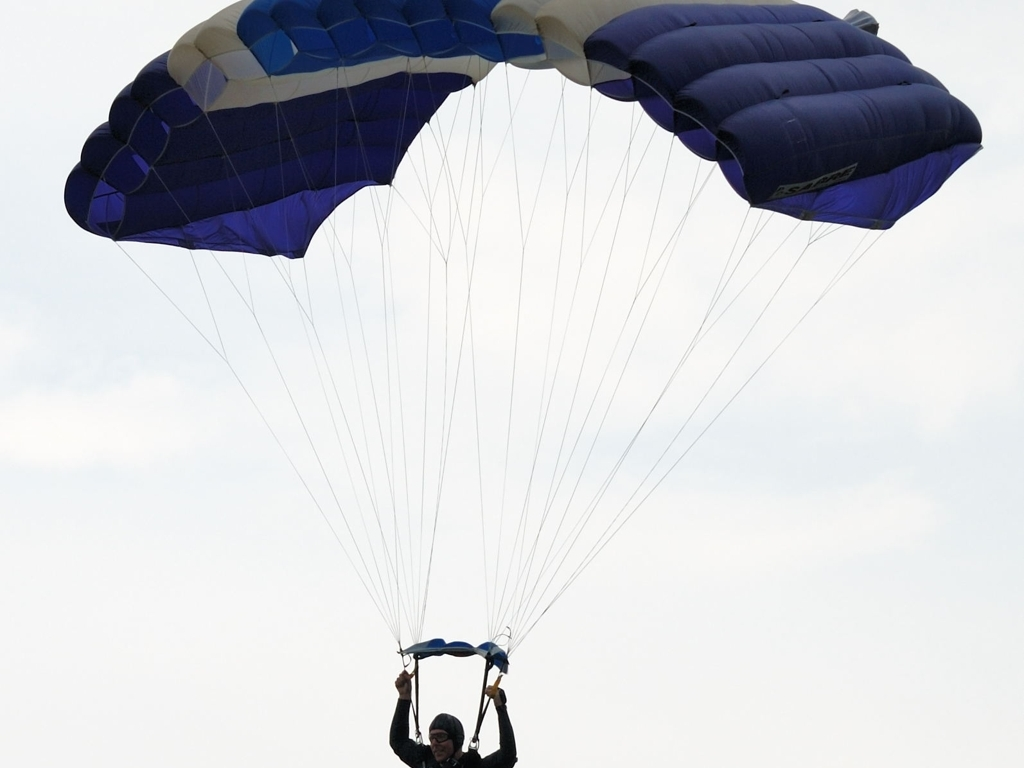Could you describe the technical aspects of the gear used in this image? Certainly! The image features a paraglider using a ram-air parachute, which is a type of non-rigid airfoil. The canopy appears to be of a rectangular shape and designed with cells that inflate from the wind during flight, creating a wing that provides lift. The harness is where the paraglider is suspended and is connected to the canopy via numerous lines that ensure stability and control. The paraglider is holding handles attached to the brake lines, which can be used to control the speed and direction of the flight. 